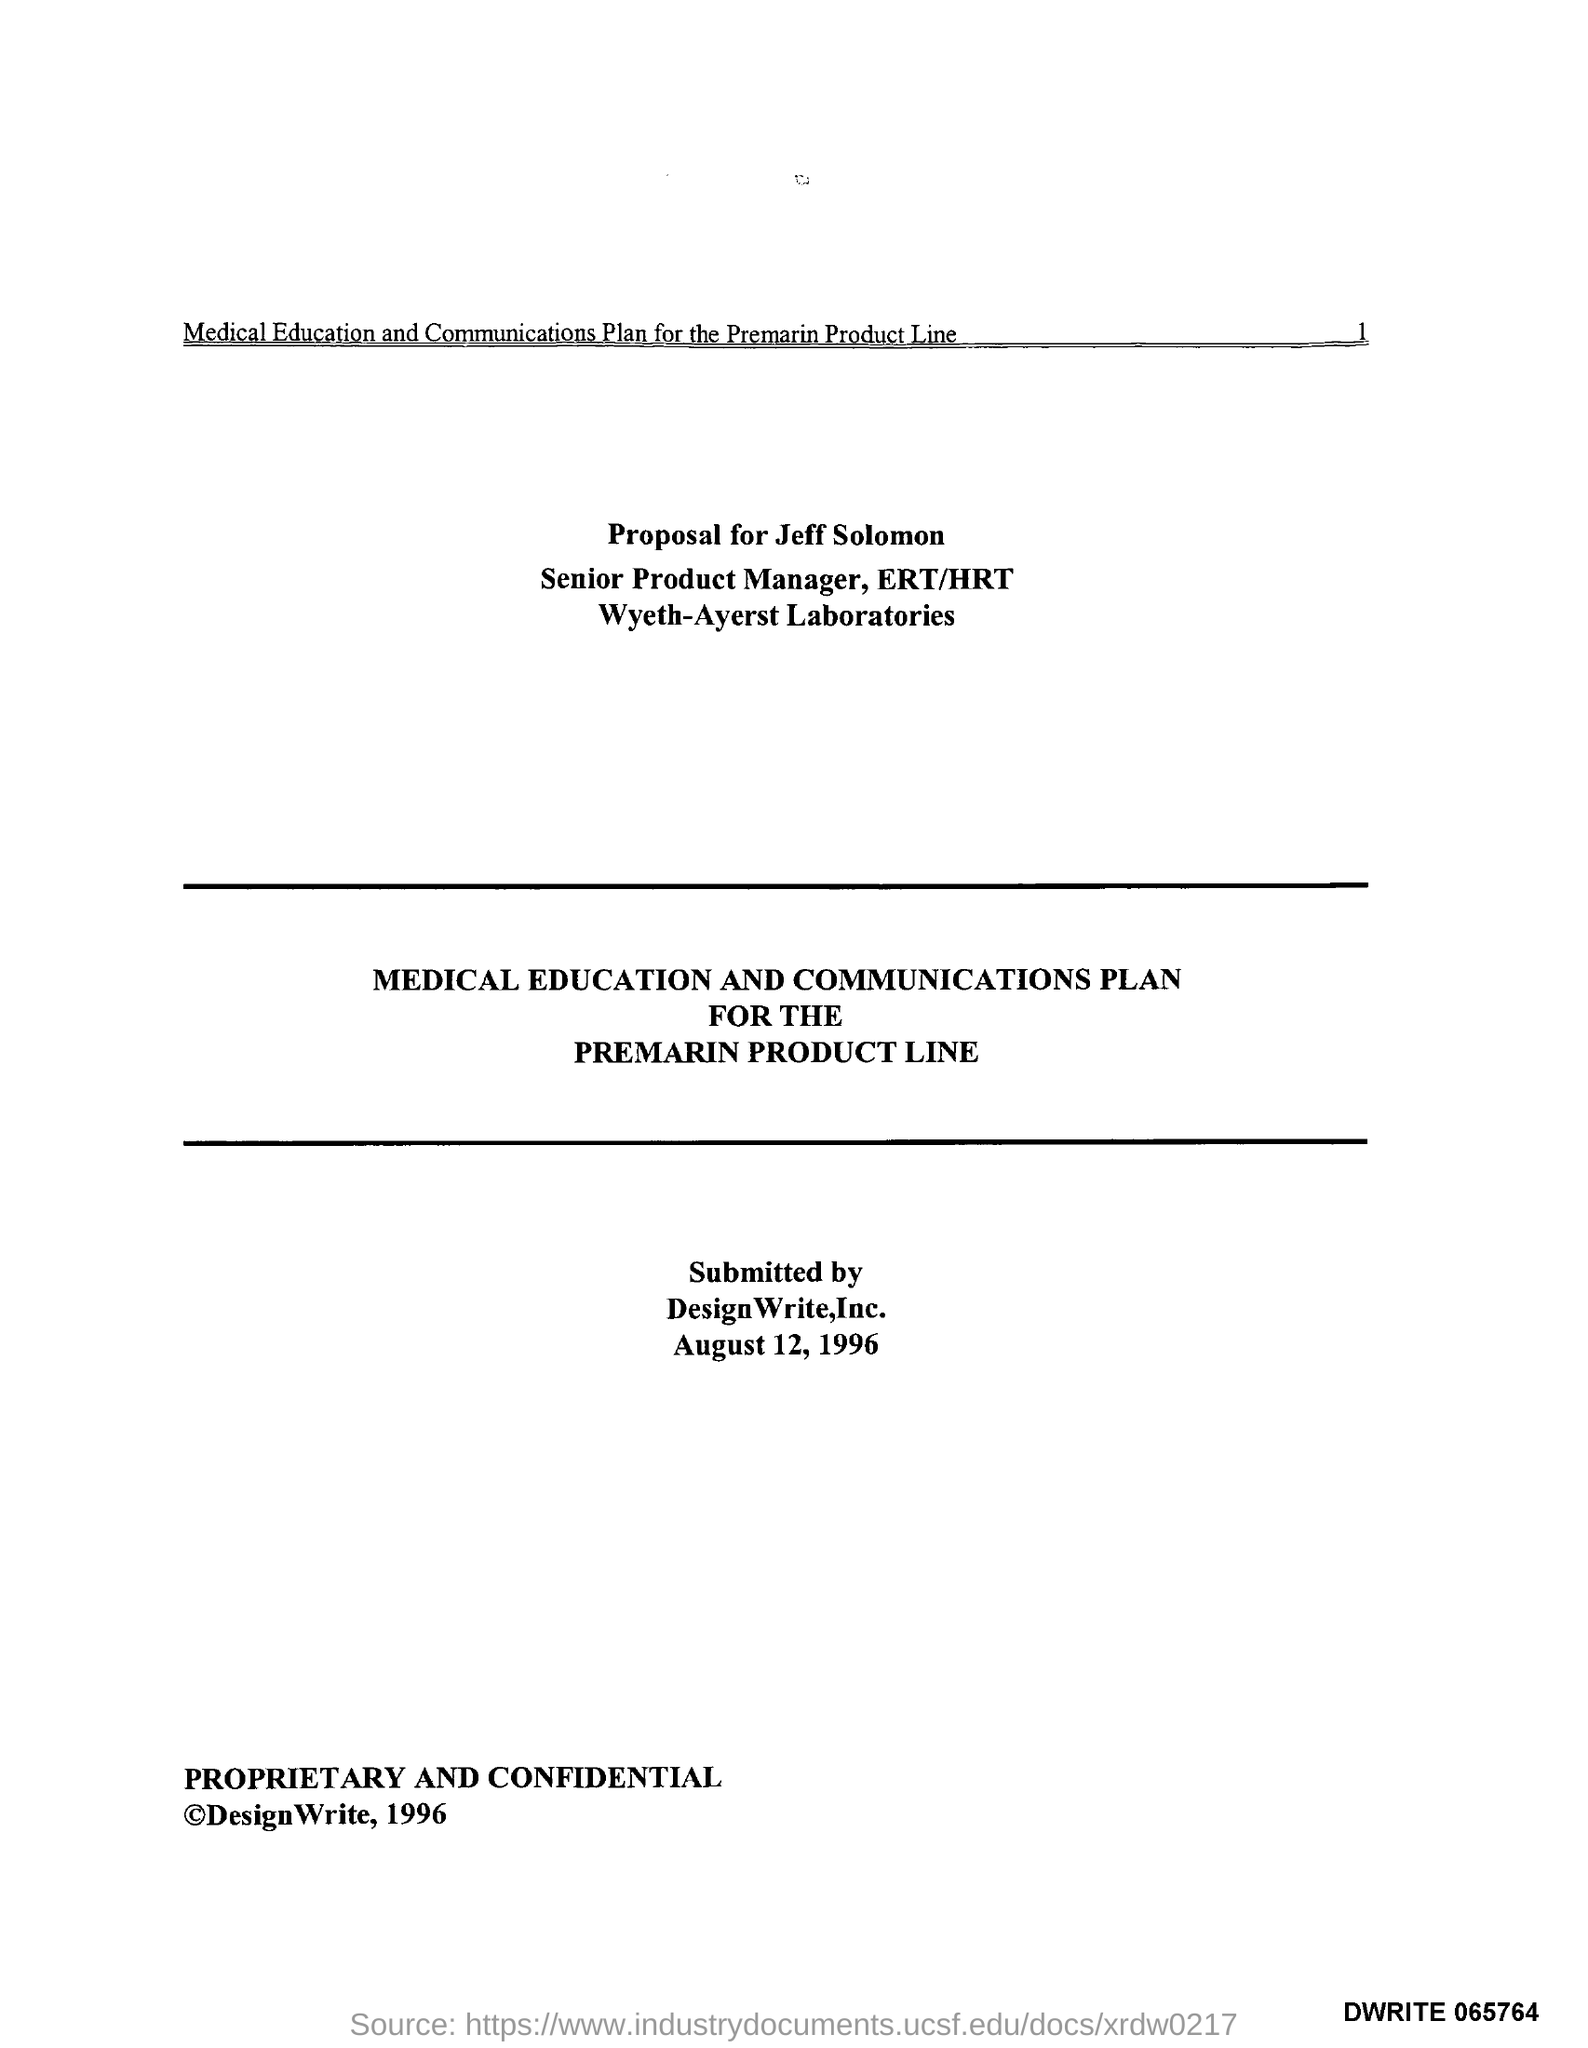Who is it submitted by?
Provide a succinct answer. DesignWrite,Inc. When was it submitted?
Your answer should be compact. August 12, 1996. 